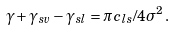<formula> <loc_0><loc_0><loc_500><loc_500>\gamma + \gamma _ { s v } - \gamma _ { s l } = \pi c _ { l s } / 4 \sigma ^ { 2 } \, .</formula> 